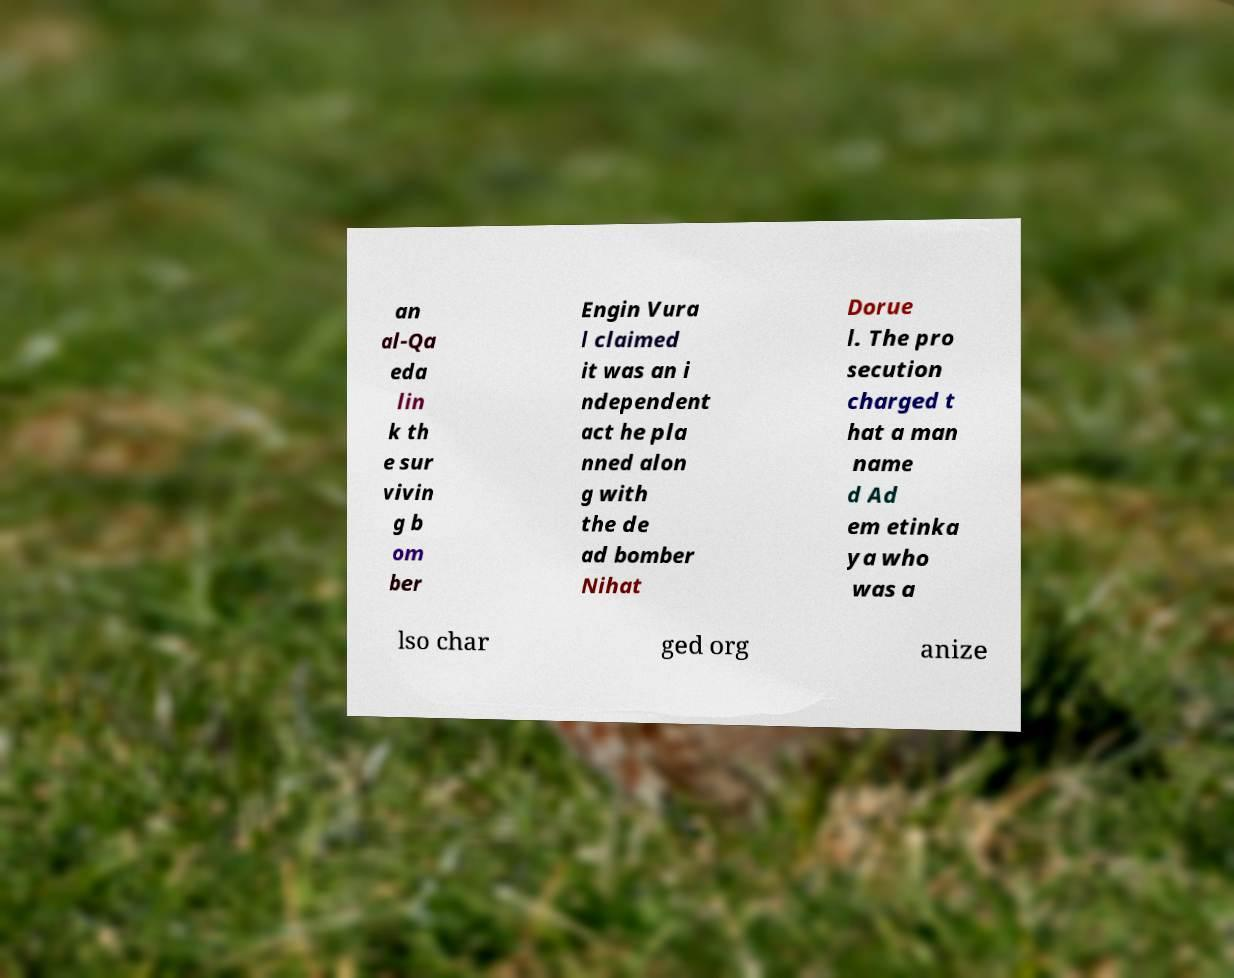Can you read and provide the text displayed in the image?This photo seems to have some interesting text. Can you extract and type it out for me? an al-Qa eda lin k th e sur vivin g b om ber Engin Vura l claimed it was an i ndependent act he pla nned alon g with the de ad bomber Nihat Dorue l. The pro secution charged t hat a man name d Ad em etinka ya who was a lso char ged org anize 